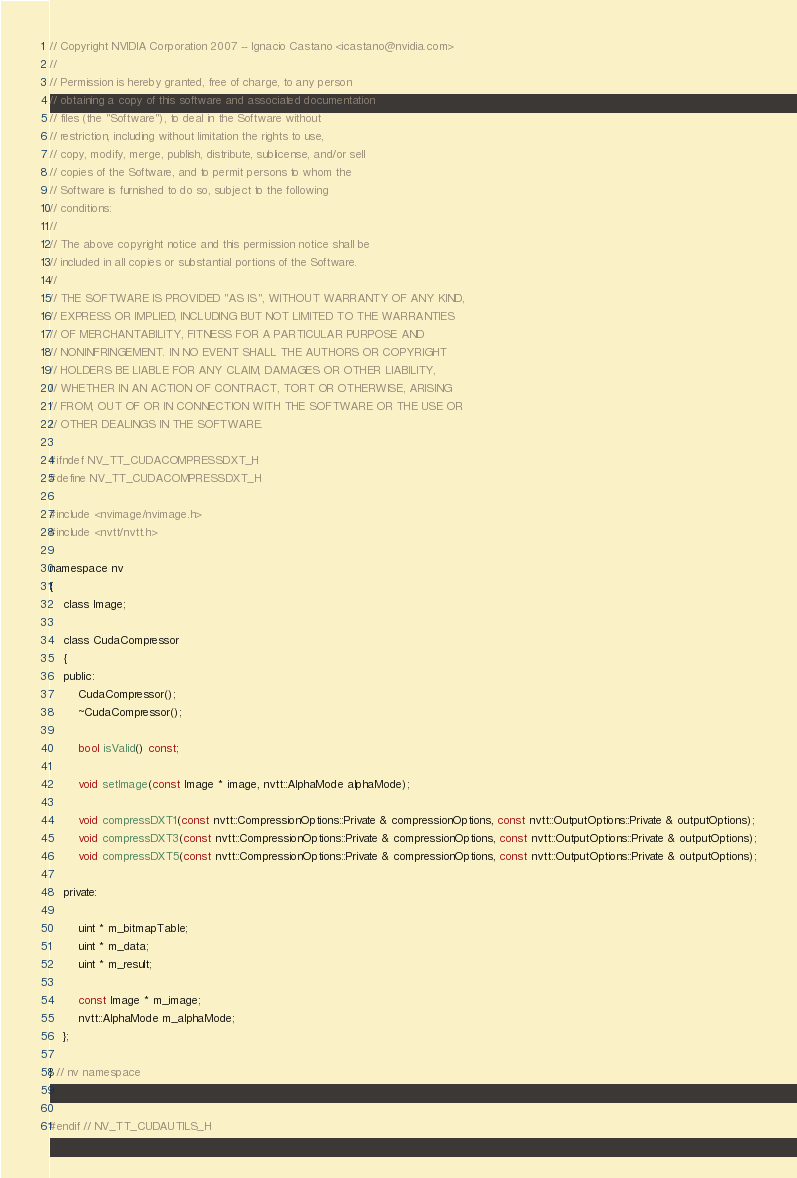Convert code to text. <code><loc_0><loc_0><loc_500><loc_500><_C_>// Copyright NVIDIA Corporation 2007 -- Ignacio Castano <icastano@nvidia.com>
// 
// Permission is hereby granted, free of charge, to any person
// obtaining a copy of this software and associated documentation
// files (the "Software"), to deal in the Software without
// restriction, including without limitation the rights to use,
// copy, modify, merge, publish, distribute, sublicense, and/or sell
// copies of the Software, and to permit persons to whom the
// Software is furnished to do so, subject to the following
// conditions:
// 
// The above copyright notice and this permission notice shall be
// included in all copies or substantial portions of the Software.
// 
// THE SOFTWARE IS PROVIDED "AS IS", WITHOUT WARRANTY OF ANY KIND,
// EXPRESS OR IMPLIED, INCLUDING BUT NOT LIMITED TO THE WARRANTIES
// OF MERCHANTABILITY, FITNESS FOR A PARTICULAR PURPOSE AND
// NONINFRINGEMENT. IN NO EVENT SHALL THE AUTHORS OR COPYRIGHT
// HOLDERS BE LIABLE FOR ANY CLAIM, DAMAGES OR OTHER LIABILITY,
// WHETHER IN AN ACTION OF CONTRACT, TORT OR OTHERWISE, ARISING
// FROM, OUT OF OR IN CONNECTION WITH THE SOFTWARE OR THE USE OR
// OTHER DEALINGS IN THE SOFTWARE.

#ifndef NV_TT_CUDACOMPRESSDXT_H
#define NV_TT_CUDACOMPRESSDXT_H

#include <nvimage/nvimage.h>
#include <nvtt/nvtt.h>

namespace nv
{
	class Image;

	class CudaCompressor
	{
	public:
		CudaCompressor();
		~CudaCompressor();

		bool isValid() const;

		void setImage(const Image * image, nvtt::AlphaMode alphaMode);

		void compressDXT1(const nvtt::CompressionOptions::Private & compressionOptions, const nvtt::OutputOptions::Private & outputOptions);
		void compressDXT3(const nvtt::CompressionOptions::Private & compressionOptions, const nvtt::OutputOptions::Private & outputOptions);
		void compressDXT5(const nvtt::CompressionOptions::Private & compressionOptions, const nvtt::OutputOptions::Private & outputOptions);

	private:

		uint * m_bitmapTable;
		uint * m_data;
		uint * m_result;
		
		const Image * m_image;
		nvtt::AlphaMode m_alphaMode;
	};

} // nv namespace


#endif // NV_TT_CUDAUTILS_H
</code> 